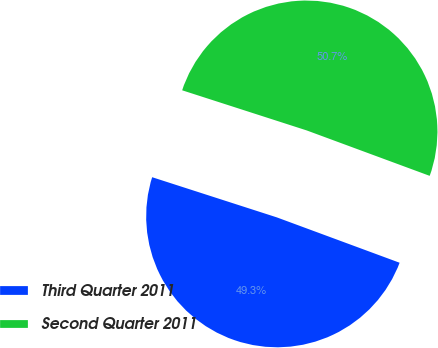Convert chart. <chart><loc_0><loc_0><loc_500><loc_500><pie_chart><fcel>Third Quarter 2011<fcel>Second Quarter 2011<nl><fcel>49.33%<fcel>50.67%<nl></chart> 